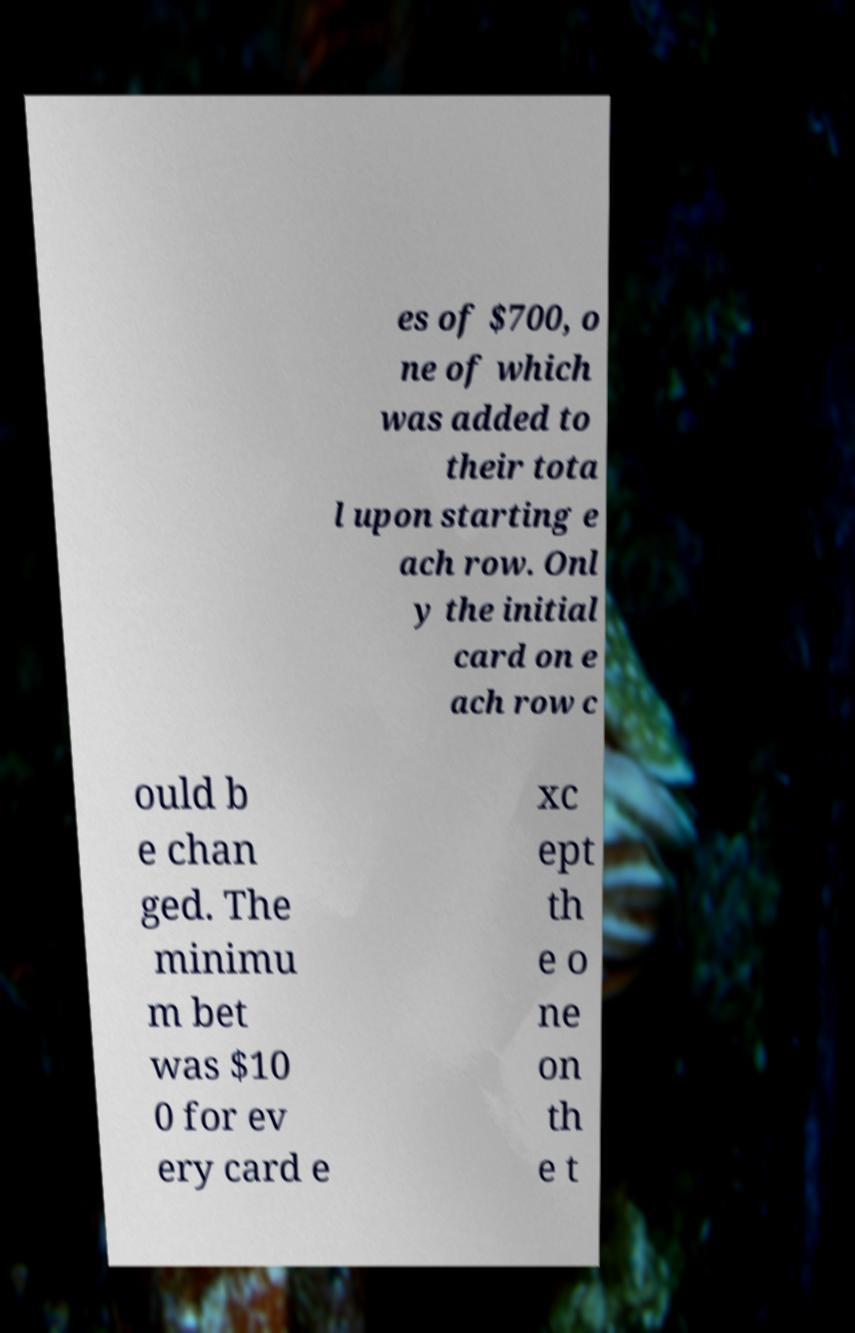Could you assist in decoding the text presented in this image and type it out clearly? es of $700, o ne of which was added to their tota l upon starting e ach row. Onl y the initial card on e ach row c ould b e chan ged. The minimu m bet was $10 0 for ev ery card e xc ept th e o ne on th e t 